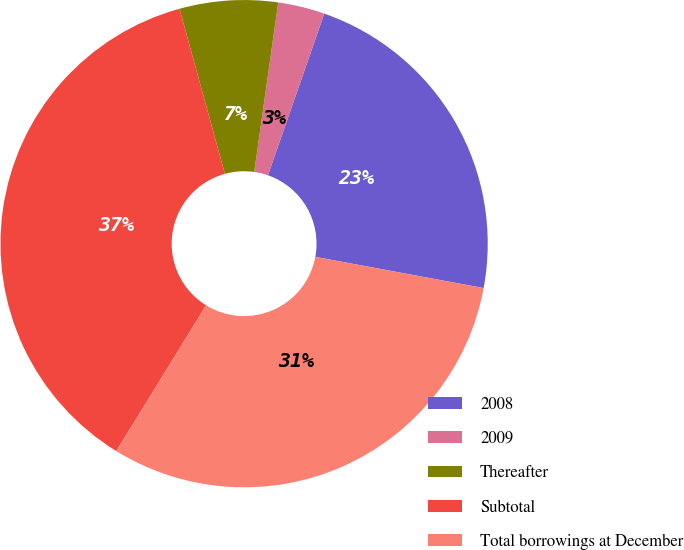Convert chart to OTSL. <chart><loc_0><loc_0><loc_500><loc_500><pie_chart><fcel>2008<fcel>2009<fcel>Thereafter<fcel>Subtotal<fcel>Total borrowings at December<nl><fcel>22.58%<fcel>3.1%<fcel>6.51%<fcel>36.94%<fcel>30.87%<nl></chart> 